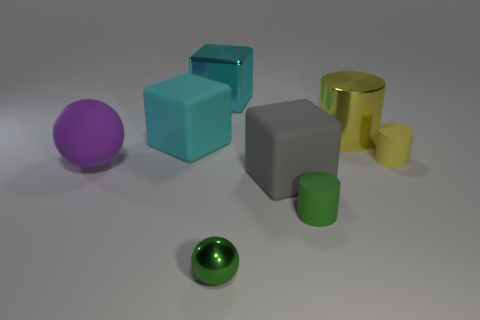Add 1 green rubber objects. How many objects exist? 9 Subtract all spheres. How many objects are left? 6 Subtract 0 purple cylinders. How many objects are left? 8 Subtract all tiny cyan shiny spheres. Subtract all big cyan rubber objects. How many objects are left? 7 Add 1 shiny spheres. How many shiny spheres are left? 2 Add 5 small green cylinders. How many small green cylinders exist? 6 